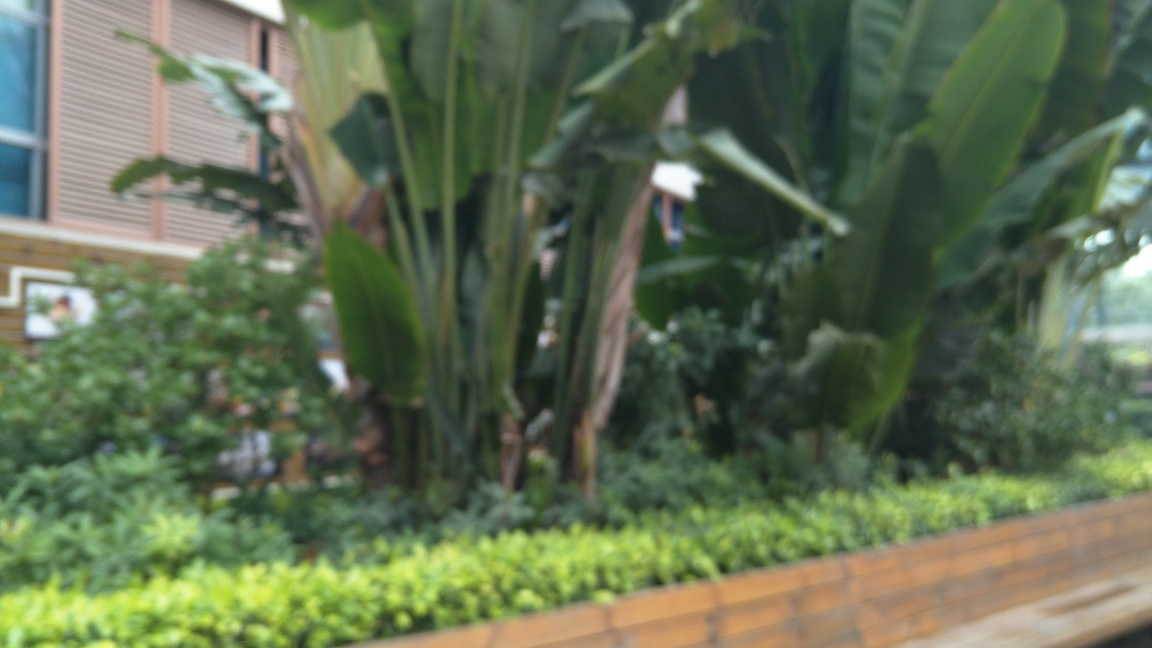Is there any noise present in this photo? The term 'noise' in photography typically refers to a visual distortion. In this photo, however, 'noise' may not be the best term to describe the quality of the image. What is evident is a significant blurriness, suggesting the photo is out of focus rather than noisy. The areas that one would expect to be crisp and detailed, such as the leaves of the plants and the brickwork, are all uniformly blurred. This suggests that the camera may have moved during the exposure or the autofocus did not lock onto a specific subject, leading to a lack of sharpness across the entire image. 